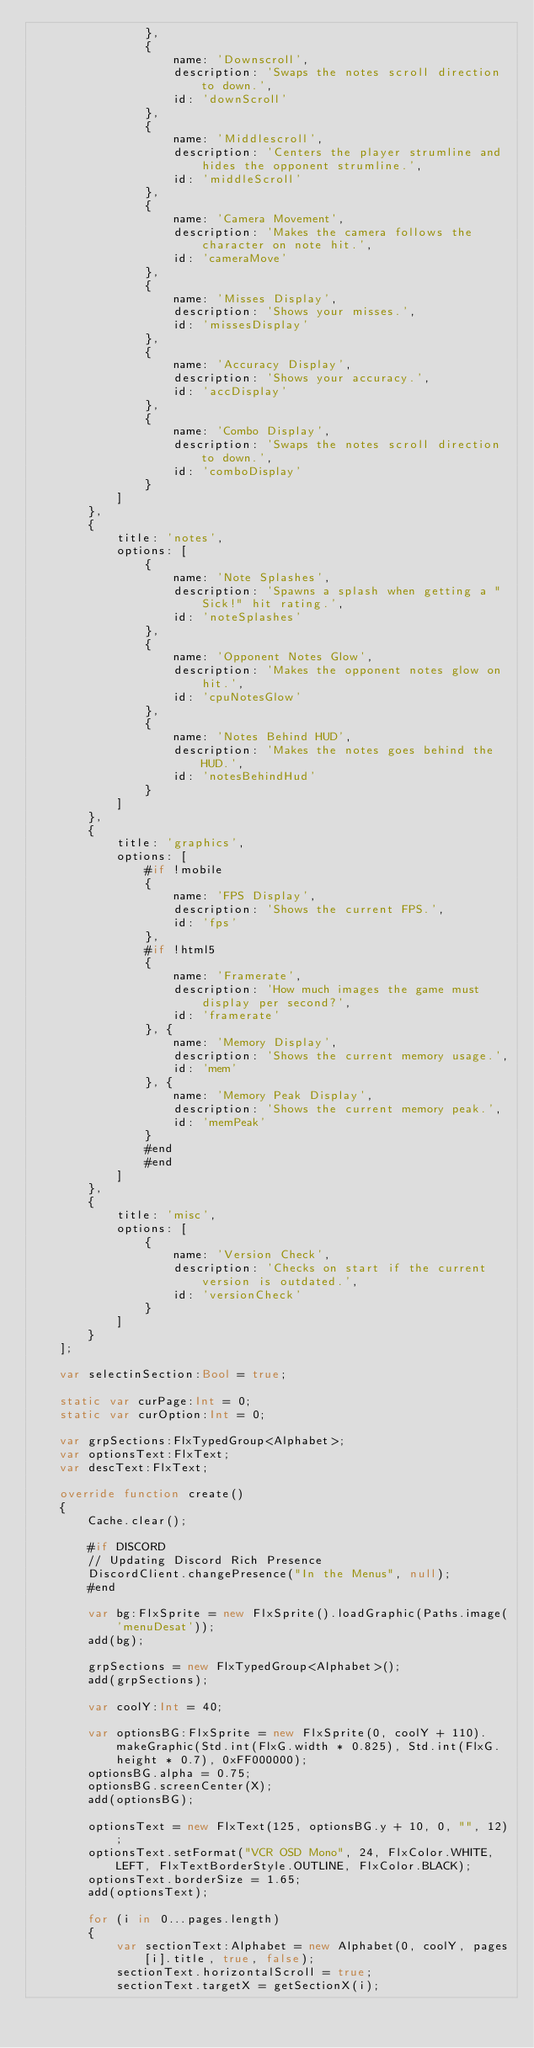Convert code to text. <code><loc_0><loc_0><loc_500><loc_500><_Haxe_>				},
				{
					name: 'Downscroll',
					description: 'Swaps the notes scroll direction to down.',
					id: 'downScroll'
				},
				{
					name: 'Middlescroll',
					description: 'Centers the player strumline and hides the opponent strumline.',
					id: 'middleScroll'
				},
				{
					name: 'Camera Movement',
					description: 'Makes the camera follows the character on note hit.',
					id: 'cameraMove'
				},
				{
					name: 'Misses Display',
					description: 'Shows your misses.',
					id: 'missesDisplay'
				},
				{
					name: 'Accuracy Display',
					description: 'Shows your accuracy.',
					id: 'accDisplay'
				},
				{
					name: 'Combo Display',
					description: 'Swaps the notes scroll direction to down.',
					id: 'comboDisplay'
				}
			]
		},
		{
			title: 'notes',
			options: [
				{
					name: 'Note Splashes',
					description: 'Spawns a splash when getting a "Sick!" hit rating.',
					id: 'noteSplashes'
				},
				{
					name: 'Opponent Notes Glow',
					description: 'Makes the opponent notes glow on hit.',
					id: 'cpuNotesGlow'
				},
				{
					name: 'Notes Behind HUD',
					description: 'Makes the notes goes behind the HUD.',
					id: 'notesBehindHud'
				}
			]
		},
		{
			title: 'graphics',
			options: [
				#if !mobile
				{
					name: 'FPS Display',
					description: 'Shows the current FPS.',
					id: 'fps'
				},
				#if !html5
				{
					name: 'Framerate',
					description: 'How much images the game must display per second?',
					id: 'framerate'
				}, {
					name: 'Memory Display',
					description: 'Shows the current memory usage.',
					id: 'mem'
				}, {
					name: 'Memory Peak Display',
					description: 'Shows the current memory peak.',
					id: 'memPeak'
				}
				#end
				#end
			]
		},
		{
			title: 'misc',
			options: [
				{
					name: 'Version Check',
					description: 'Checks on start if the current version is outdated.',
					id: 'versionCheck'
				}
			]
		}
	];

	var selectinSection:Bool = true;

	static var curPage:Int = 0;
	static var curOption:Int = 0;

	var grpSections:FlxTypedGroup<Alphabet>;
	var optionsText:FlxText;
	var descText:FlxText;

	override function create()
	{
		Cache.clear();

		#if DISCORD
		// Updating Discord Rich Presence
		DiscordClient.changePresence("In the Menus", null);
		#end

		var bg:FlxSprite = new FlxSprite().loadGraphic(Paths.image('menuDesat'));
		add(bg);

		grpSections = new FlxTypedGroup<Alphabet>();
		add(grpSections);

		var coolY:Int = 40;

		var optionsBG:FlxSprite = new FlxSprite(0, coolY + 110).makeGraphic(Std.int(FlxG.width * 0.825), Std.int(FlxG.height * 0.7), 0xFF000000);
		optionsBG.alpha = 0.75;
		optionsBG.screenCenter(X);
		add(optionsBG);

		optionsText = new FlxText(125, optionsBG.y + 10, 0, "", 12);
		optionsText.setFormat("VCR OSD Mono", 24, FlxColor.WHITE, LEFT, FlxTextBorderStyle.OUTLINE, FlxColor.BLACK);
		optionsText.borderSize = 1.65;
		add(optionsText);

		for (i in 0...pages.length)
		{
			var sectionText:Alphabet = new Alphabet(0, coolY, pages[i].title, true, false);
			sectionText.horizontalScroll = true;
			sectionText.targetX = getSectionX(i);</code> 